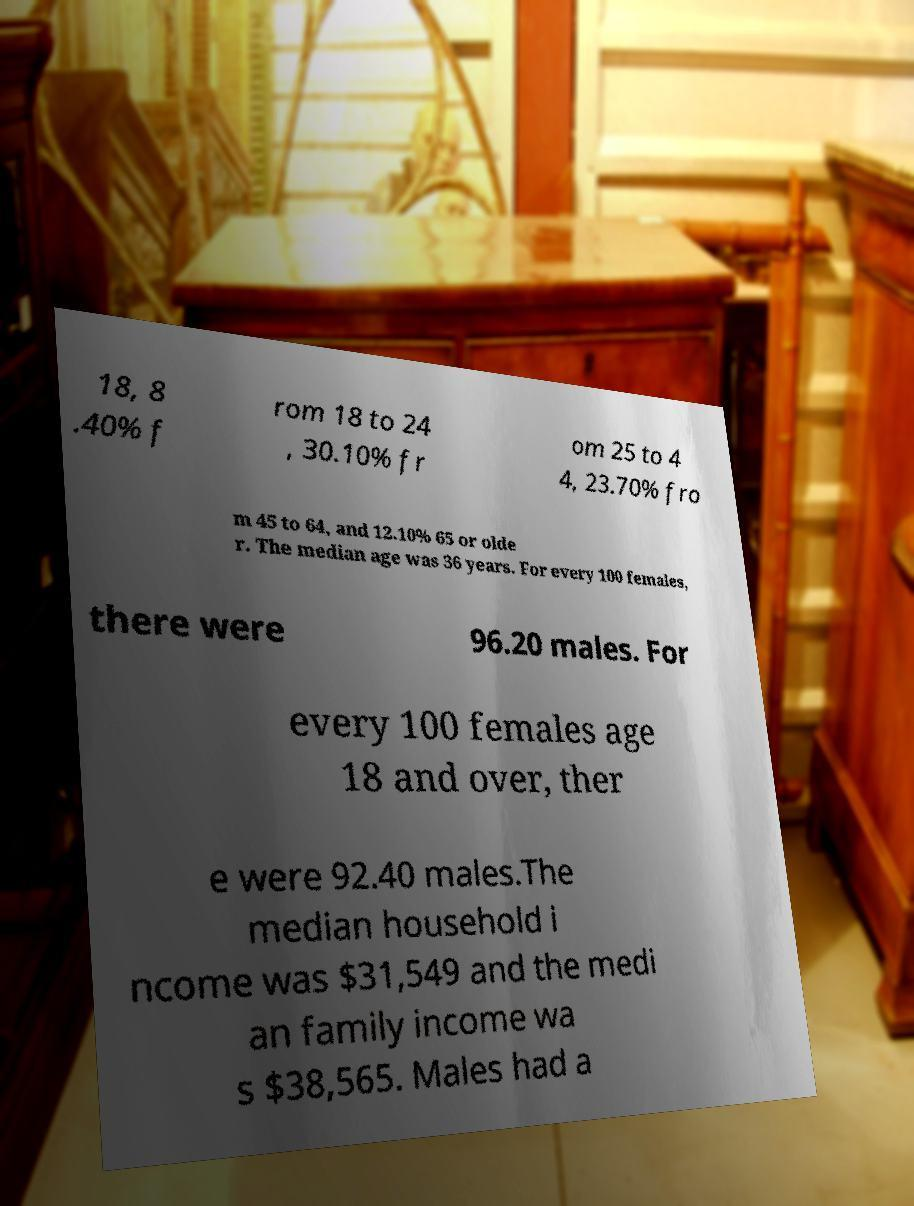Can you accurately transcribe the text from the provided image for me? 18, 8 .40% f rom 18 to 24 , 30.10% fr om 25 to 4 4, 23.70% fro m 45 to 64, and 12.10% 65 or olde r. The median age was 36 years. For every 100 females, there were 96.20 males. For every 100 females age 18 and over, ther e were 92.40 males.The median household i ncome was $31,549 and the medi an family income wa s $38,565. Males had a 